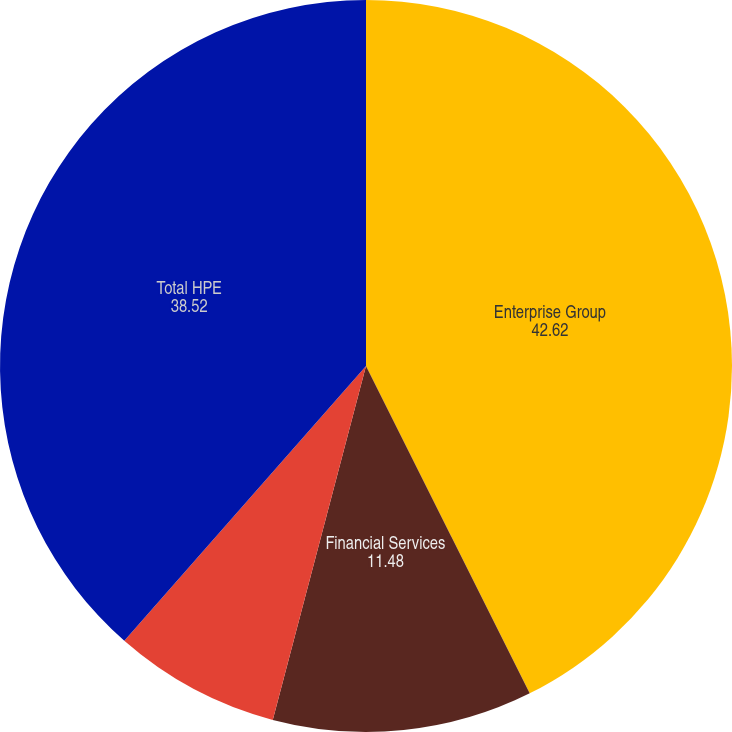<chart> <loc_0><loc_0><loc_500><loc_500><pie_chart><fcel>Enterprise Group<fcel>Financial Services<fcel>Corporate Investments/Other<fcel>Total HPE<nl><fcel>42.62%<fcel>11.48%<fcel>7.38%<fcel>38.52%<nl></chart> 